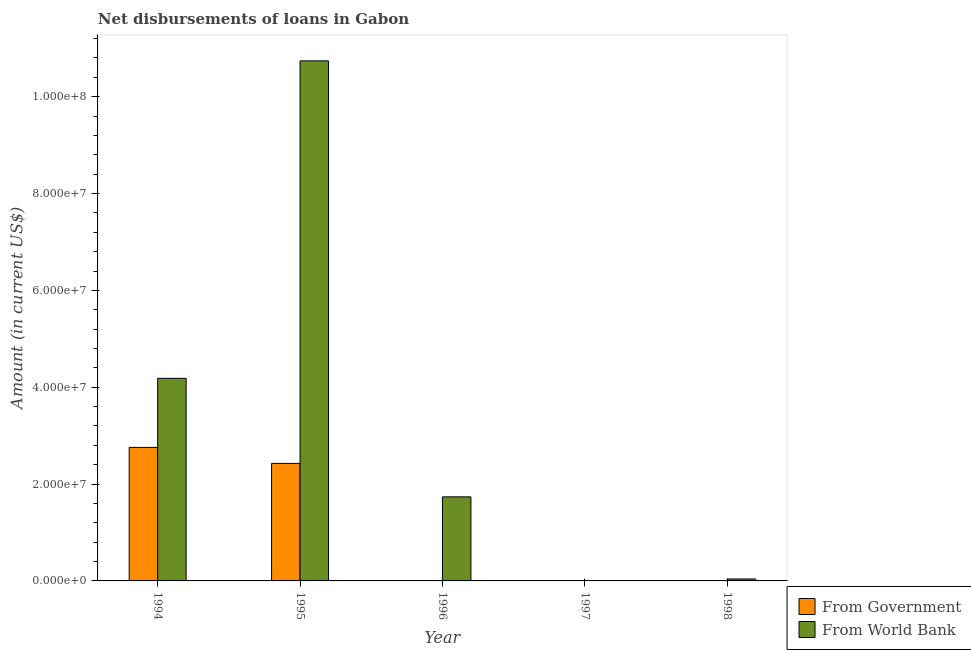Are the number of bars per tick equal to the number of legend labels?
Give a very brief answer. No. How many bars are there on the 3rd tick from the left?
Offer a terse response. 1. What is the net disbursements of loan from government in 1998?
Offer a very short reply. 0. Across all years, what is the maximum net disbursements of loan from government?
Give a very brief answer. 2.76e+07. What is the total net disbursements of loan from government in the graph?
Offer a terse response. 5.18e+07. What is the difference between the net disbursements of loan from world bank in 1996 and that in 1998?
Your answer should be compact. 1.70e+07. What is the difference between the net disbursements of loan from government in 1994 and the net disbursements of loan from world bank in 1996?
Make the answer very short. 2.76e+07. What is the average net disbursements of loan from government per year?
Offer a terse response. 1.04e+07. What is the ratio of the net disbursements of loan from world bank in 1995 to that in 1996?
Ensure brevity in your answer.  6.19. Is the net disbursements of loan from world bank in 1996 less than that in 1998?
Give a very brief answer. No. What is the difference between the highest and the second highest net disbursements of loan from world bank?
Keep it short and to the point. 6.55e+07. What is the difference between the highest and the lowest net disbursements of loan from world bank?
Offer a terse response. 1.07e+08. In how many years, is the net disbursements of loan from government greater than the average net disbursements of loan from government taken over all years?
Your answer should be compact. 2. How many bars are there?
Make the answer very short. 6. How many years are there in the graph?
Provide a succinct answer. 5. Does the graph contain any zero values?
Provide a succinct answer. Yes. Does the graph contain grids?
Your answer should be compact. No. How many legend labels are there?
Make the answer very short. 2. How are the legend labels stacked?
Offer a very short reply. Vertical. What is the title of the graph?
Give a very brief answer. Net disbursements of loans in Gabon. Does "Primary completion rate" appear as one of the legend labels in the graph?
Give a very brief answer. No. What is the label or title of the X-axis?
Ensure brevity in your answer.  Year. What is the label or title of the Y-axis?
Ensure brevity in your answer.  Amount (in current US$). What is the Amount (in current US$) in From Government in 1994?
Your answer should be compact. 2.76e+07. What is the Amount (in current US$) in From World Bank in 1994?
Ensure brevity in your answer.  4.18e+07. What is the Amount (in current US$) of From Government in 1995?
Your answer should be very brief. 2.43e+07. What is the Amount (in current US$) in From World Bank in 1995?
Your response must be concise. 1.07e+08. What is the Amount (in current US$) of From World Bank in 1996?
Give a very brief answer. 1.74e+07. What is the Amount (in current US$) of From World Bank in 1997?
Offer a terse response. 0. What is the Amount (in current US$) in From World Bank in 1998?
Make the answer very short. 4.01e+05. Across all years, what is the maximum Amount (in current US$) of From Government?
Offer a very short reply. 2.76e+07. Across all years, what is the maximum Amount (in current US$) in From World Bank?
Offer a terse response. 1.07e+08. What is the total Amount (in current US$) in From Government in the graph?
Ensure brevity in your answer.  5.18e+07. What is the total Amount (in current US$) of From World Bank in the graph?
Offer a very short reply. 1.67e+08. What is the difference between the Amount (in current US$) of From Government in 1994 and that in 1995?
Ensure brevity in your answer.  3.30e+06. What is the difference between the Amount (in current US$) in From World Bank in 1994 and that in 1995?
Provide a succinct answer. -6.55e+07. What is the difference between the Amount (in current US$) of From World Bank in 1994 and that in 1996?
Your answer should be very brief. 2.45e+07. What is the difference between the Amount (in current US$) of From World Bank in 1994 and that in 1998?
Make the answer very short. 4.14e+07. What is the difference between the Amount (in current US$) of From World Bank in 1995 and that in 1996?
Provide a succinct answer. 9.00e+07. What is the difference between the Amount (in current US$) of From World Bank in 1995 and that in 1998?
Offer a terse response. 1.07e+08. What is the difference between the Amount (in current US$) in From World Bank in 1996 and that in 1998?
Give a very brief answer. 1.70e+07. What is the difference between the Amount (in current US$) of From Government in 1994 and the Amount (in current US$) of From World Bank in 1995?
Your response must be concise. -7.98e+07. What is the difference between the Amount (in current US$) of From Government in 1994 and the Amount (in current US$) of From World Bank in 1996?
Your response must be concise. 1.02e+07. What is the difference between the Amount (in current US$) of From Government in 1994 and the Amount (in current US$) of From World Bank in 1998?
Offer a terse response. 2.72e+07. What is the difference between the Amount (in current US$) of From Government in 1995 and the Amount (in current US$) of From World Bank in 1996?
Ensure brevity in your answer.  6.91e+06. What is the difference between the Amount (in current US$) in From Government in 1995 and the Amount (in current US$) in From World Bank in 1998?
Provide a succinct answer. 2.39e+07. What is the average Amount (in current US$) of From Government per year?
Offer a terse response. 1.04e+07. What is the average Amount (in current US$) of From World Bank per year?
Provide a succinct answer. 3.34e+07. In the year 1994, what is the difference between the Amount (in current US$) of From Government and Amount (in current US$) of From World Bank?
Your response must be concise. -1.43e+07. In the year 1995, what is the difference between the Amount (in current US$) of From Government and Amount (in current US$) of From World Bank?
Keep it short and to the point. -8.31e+07. What is the ratio of the Amount (in current US$) of From Government in 1994 to that in 1995?
Give a very brief answer. 1.14. What is the ratio of the Amount (in current US$) of From World Bank in 1994 to that in 1995?
Provide a short and direct response. 0.39. What is the ratio of the Amount (in current US$) of From World Bank in 1994 to that in 1996?
Provide a short and direct response. 2.41. What is the ratio of the Amount (in current US$) of From World Bank in 1994 to that in 1998?
Provide a short and direct response. 104.35. What is the ratio of the Amount (in current US$) of From World Bank in 1995 to that in 1996?
Ensure brevity in your answer.  6.19. What is the ratio of the Amount (in current US$) in From World Bank in 1995 to that in 1998?
Give a very brief answer. 267.81. What is the ratio of the Amount (in current US$) in From World Bank in 1996 to that in 1998?
Offer a terse response. 43.29. What is the difference between the highest and the second highest Amount (in current US$) of From World Bank?
Give a very brief answer. 6.55e+07. What is the difference between the highest and the lowest Amount (in current US$) in From Government?
Offer a very short reply. 2.76e+07. What is the difference between the highest and the lowest Amount (in current US$) in From World Bank?
Your response must be concise. 1.07e+08. 